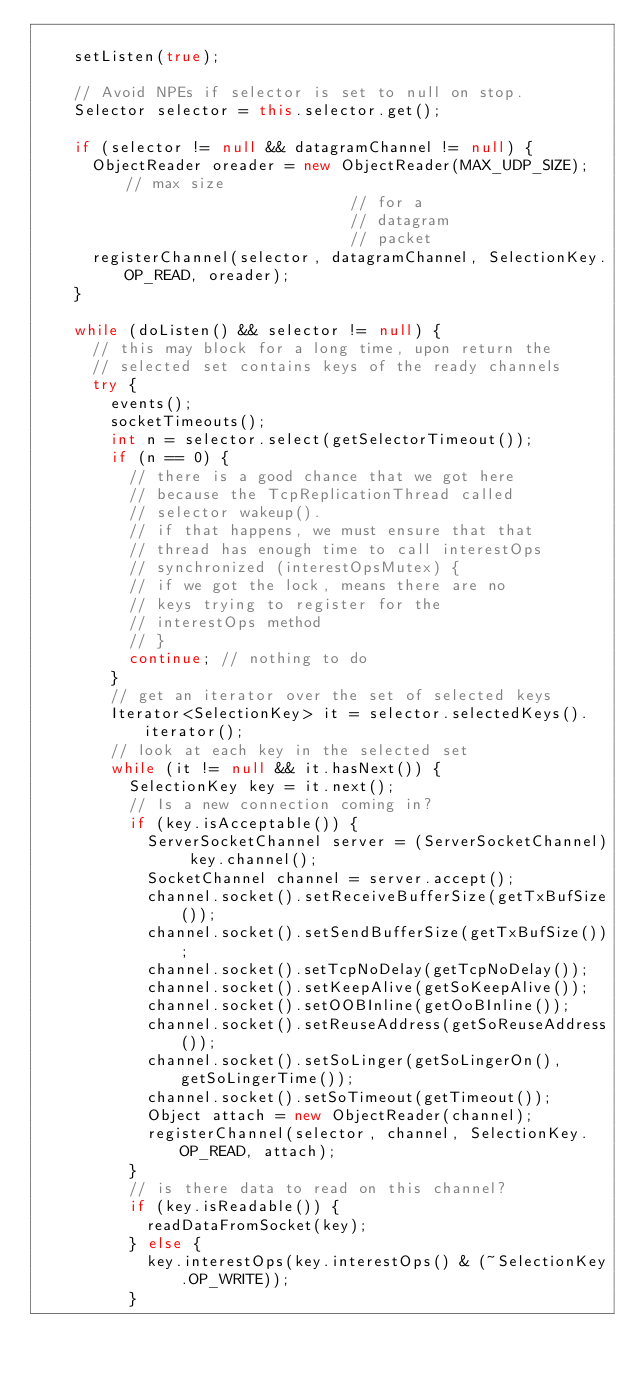<code> <loc_0><loc_0><loc_500><loc_500><_Java_>
		setListen(true);

		// Avoid NPEs if selector is set to null on stop.
		Selector selector = this.selector.get();

		if (selector != null && datagramChannel != null) {
			ObjectReader oreader = new ObjectReader(MAX_UDP_SIZE); // max size
																	// for a
																	// datagram
																	// packet
			registerChannel(selector, datagramChannel, SelectionKey.OP_READ, oreader);
		}

		while (doListen() && selector != null) {
			// this may block for a long time, upon return the
			// selected set contains keys of the ready channels
			try {
				events();
				socketTimeouts();
				int n = selector.select(getSelectorTimeout());
				if (n == 0) {
					// there is a good chance that we got here
					// because the TcpReplicationThread called
					// selector wakeup().
					// if that happens, we must ensure that that
					// thread has enough time to call interestOps
					// synchronized (interestOpsMutex) {
					// if we got the lock, means there are no
					// keys trying to register for the
					// interestOps method
					// }
					continue; // nothing to do
				}
				// get an iterator over the set of selected keys
				Iterator<SelectionKey> it = selector.selectedKeys().iterator();
				// look at each key in the selected set
				while (it != null && it.hasNext()) {
					SelectionKey key = it.next();
					// Is a new connection coming in?
					if (key.isAcceptable()) {
						ServerSocketChannel server = (ServerSocketChannel) key.channel();
						SocketChannel channel = server.accept();
						channel.socket().setReceiveBufferSize(getTxBufSize());
						channel.socket().setSendBufferSize(getTxBufSize());
						channel.socket().setTcpNoDelay(getTcpNoDelay());
						channel.socket().setKeepAlive(getSoKeepAlive());
						channel.socket().setOOBInline(getOoBInline());
						channel.socket().setReuseAddress(getSoReuseAddress());
						channel.socket().setSoLinger(getSoLingerOn(), getSoLingerTime());
						channel.socket().setSoTimeout(getTimeout());
						Object attach = new ObjectReader(channel);
						registerChannel(selector, channel, SelectionKey.OP_READ, attach);
					}
					// is there data to read on this channel?
					if (key.isReadable()) {
						readDataFromSocket(key);
					} else {
						key.interestOps(key.interestOps() & (~SelectionKey.OP_WRITE));
					}
</code> 